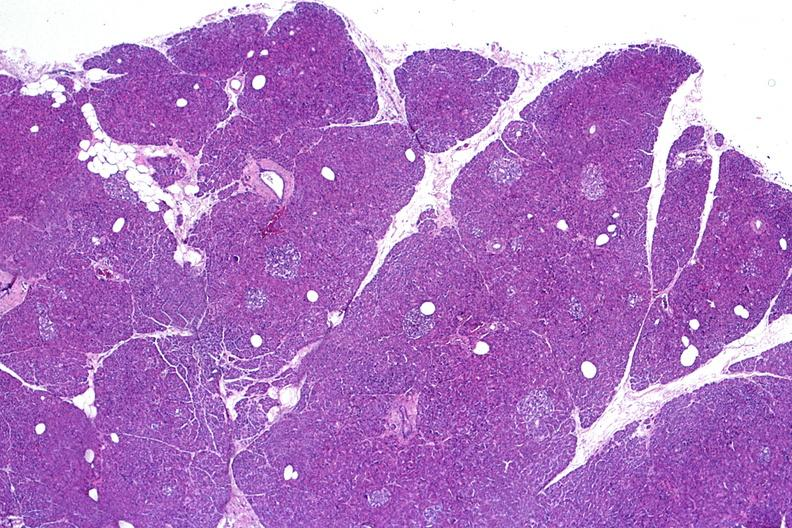does this image show normal pancreas?
Answer the question using a single word or phrase. Yes 